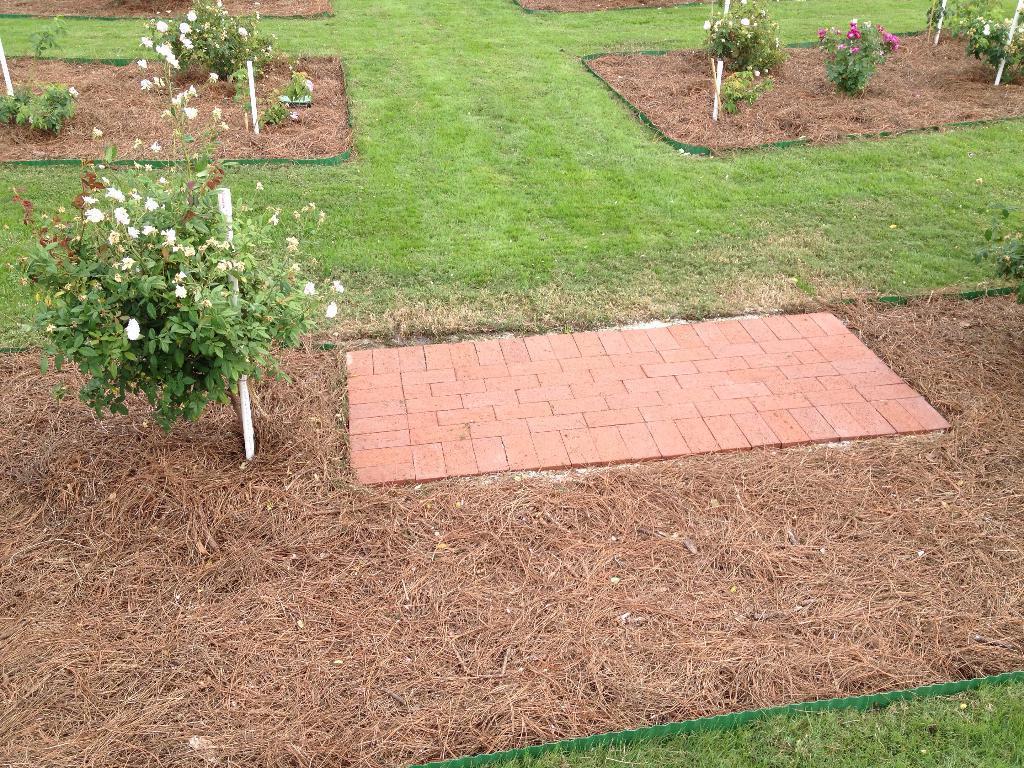Can you describe this image briefly? In this picture we can see plants, flowers, and grass. 